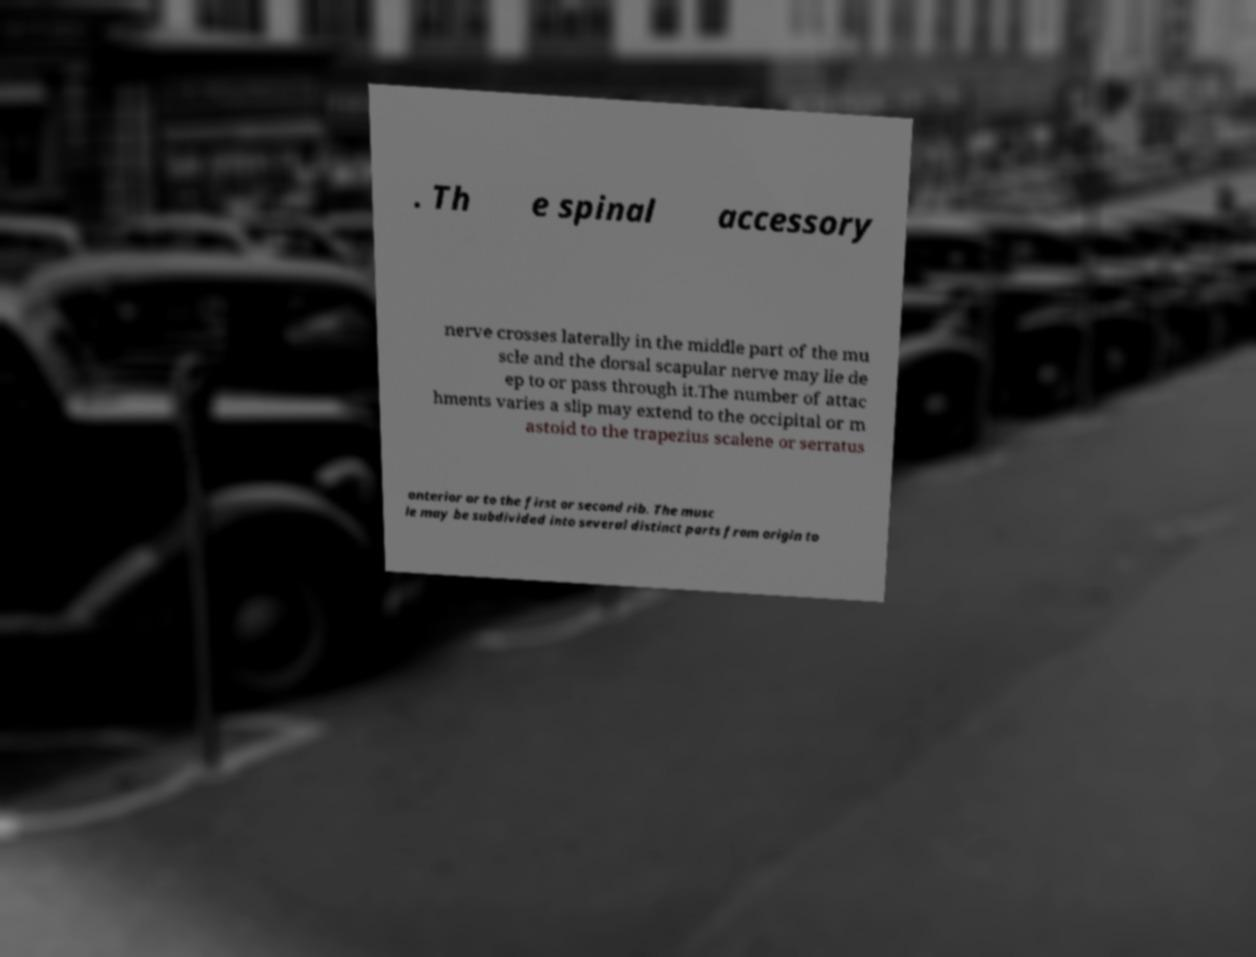I need the written content from this picture converted into text. Can you do that? . Th e spinal accessory nerve crosses laterally in the middle part of the mu scle and the dorsal scapular nerve may lie de ep to or pass through it.The number of attac hments varies a slip may extend to the occipital or m astoid to the trapezius scalene or serratus anterior or to the first or second rib. The musc le may be subdivided into several distinct parts from origin to 